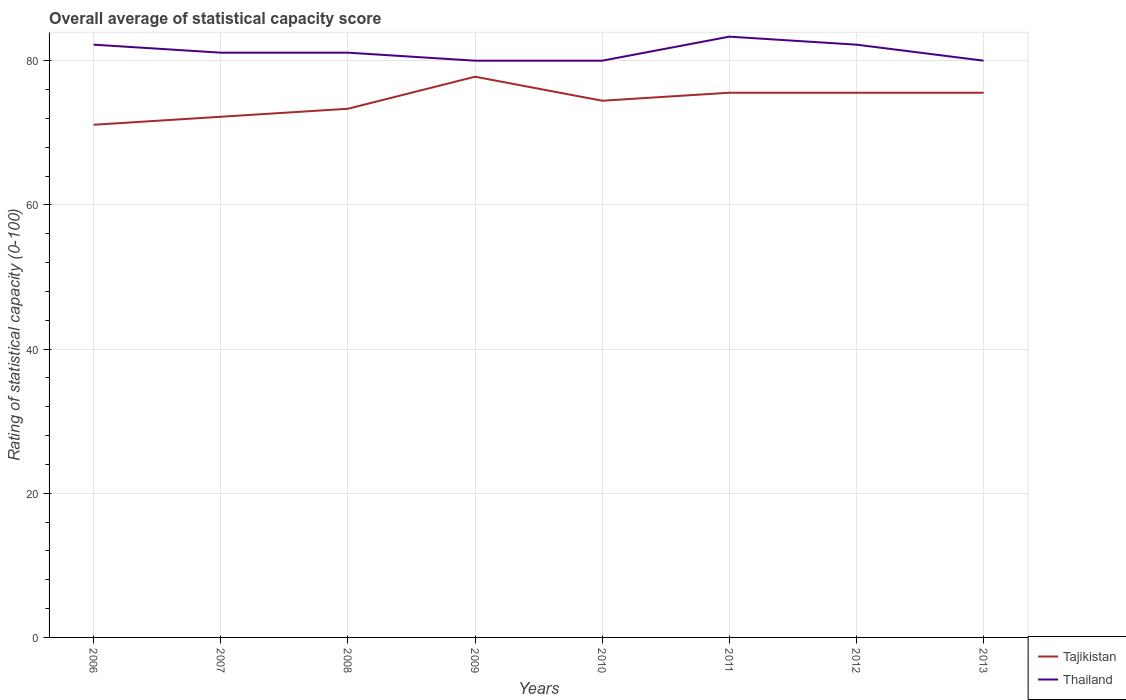Does the line corresponding to Thailand intersect with the line corresponding to Tajikistan?
Keep it short and to the point. No. Is the number of lines equal to the number of legend labels?
Make the answer very short. Yes. What is the total rating of statistical capacity in Tajikistan in the graph?
Offer a very short reply. -2.22. What is the difference between the highest and the second highest rating of statistical capacity in Thailand?
Keep it short and to the point. 3.33. How many lines are there?
Provide a succinct answer. 2. How many years are there in the graph?
Your answer should be compact. 8. Does the graph contain grids?
Keep it short and to the point. Yes. Where does the legend appear in the graph?
Keep it short and to the point. Bottom right. How are the legend labels stacked?
Your response must be concise. Vertical. What is the title of the graph?
Ensure brevity in your answer.  Overall average of statistical capacity score. Does "Liechtenstein" appear as one of the legend labels in the graph?
Keep it short and to the point. No. What is the label or title of the Y-axis?
Your answer should be very brief. Rating of statistical capacity (0-100). What is the Rating of statistical capacity (0-100) in Tajikistan in 2006?
Your answer should be compact. 71.11. What is the Rating of statistical capacity (0-100) in Thailand in 2006?
Keep it short and to the point. 82.22. What is the Rating of statistical capacity (0-100) of Tajikistan in 2007?
Offer a very short reply. 72.22. What is the Rating of statistical capacity (0-100) of Thailand in 2007?
Provide a succinct answer. 81.11. What is the Rating of statistical capacity (0-100) in Tajikistan in 2008?
Your answer should be compact. 73.33. What is the Rating of statistical capacity (0-100) in Thailand in 2008?
Your response must be concise. 81.11. What is the Rating of statistical capacity (0-100) of Tajikistan in 2009?
Offer a terse response. 77.78. What is the Rating of statistical capacity (0-100) of Tajikistan in 2010?
Provide a short and direct response. 74.44. What is the Rating of statistical capacity (0-100) of Tajikistan in 2011?
Provide a short and direct response. 75.56. What is the Rating of statistical capacity (0-100) in Thailand in 2011?
Give a very brief answer. 83.33. What is the Rating of statistical capacity (0-100) in Tajikistan in 2012?
Give a very brief answer. 75.56. What is the Rating of statistical capacity (0-100) of Thailand in 2012?
Ensure brevity in your answer.  82.22. What is the Rating of statistical capacity (0-100) in Tajikistan in 2013?
Your answer should be compact. 75.56. What is the Rating of statistical capacity (0-100) in Thailand in 2013?
Offer a terse response. 80. Across all years, what is the maximum Rating of statistical capacity (0-100) in Tajikistan?
Your answer should be compact. 77.78. Across all years, what is the maximum Rating of statistical capacity (0-100) in Thailand?
Give a very brief answer. 83.33. Across all years, what is the minimum Rating of statistical capacity (0-100) of Tajikistan?
Your response must be concise. 71.11. What is the total Rating of statistical capacity (0-100) in Tajikistan in the graph?
Provide a succinct answer. 595.56. What is the total Rating of statistical capacity (0-100) in Thailand in the graph?
Make the answer very short. 650. What is the difference between the Rating of statistical capacity (0-100) of Tajikistan in 2006 and that in 2007?
Your answer should be compact. -1.11. What is the difference between the Rating of statistical capacity (0-100) of Tajikistan in 2006 and that in 2008?
Give a very brief answer. -2.22. What is the difference between the Rating of statistical capacity (0-100) in Tajikistan in 2006 and that in 2009?
Your answer should be compact. -6.67. What is the difference between the Rating of statistical capacity (0-100) of Thailand in 2006 and that in 2009?
Ensure brevity in your answer.  2.22. What is the difference between the Rating of statistical capacity (0-100) in Thailand in 2006 and that in 2010?
Provide a succinct answer. 2.22. What is the difference between the Rating of statistical capacity (0-100) in Tajikistan in 2006 and that in 2011?
Your response must be concise. -4.44. What is the difference between the Rating of statistical capacity (0-100) in Thailand in 2006 and that in 2011?
Your response must be concise. -1.11. What is the difference between the Rating of statistical capacity (0-100) of Tajikistan in 2006 and that in 2012?
Offer a very short reply. -4.44. What is the difference between the Rating of statistical capacity (0-100) in Thailand in 2006 and that in 2012?
Provide a succinct answer. 0. What is the difference between the Rating of statistical capacity (0-100) of Tajikistan in 2006 and that in 2013?
Your answer should be very brief. -4.44. What is the difference between the Rating of statistical capacity (0-100) of Thailand in 2006 and that in 2013?
Your response must be concise. 2.22. What is the difference between the Rating of statistical capacity (0-100) of Tajikistan in 2007 and that in 2008?
Provide a short and direct response. -1.11. What is the difference between the Rating of statistical capacity (0-100) of Tajikistan in 2007 and that in 2009?
Keep it short and to the point. -5.56. What is the difference between the Rating of statistical capacity (0-100) of Tajikistan in 2007 and that in 2010?
Keep it short and to the point. -2.22. What is the difference between the Rating of statistical capacity (0-100) in Tajikistan in 2007 and that in 2011?
Give a very brief answer. -3.33. What is the difference between the Rating of statistical capacity (0-100) of Thailand in 2007 and that in 2011?
Your answer should be compact. -2.22. What is the difference between the Rating of statistical capacity (0-100) in Tajikistan in 2007 and that in 2012?
Your answer should be compact. -3.33. What is the difference between the Rating of statistical capacity (0-100) in Thailand in 2007 and that in 2012?
Your response must be concise. -1.11. What is the difference between the Rating of statistical capacity (0-100) of Tajikistan in 2008 and that in 2009?
Your response must be concise. -4.44. What is the difference between the Rating of statistical capacity (0-100) of Thailand in 2008 and that in 2009?
Provide a succinct answer. 1.11. What is the difference between the Rating of statistical capacity (0-100) in Tajikistan in 2008 and that in 2010?
Make the answer very short. -1.11. What is the difference between the Rating of statistical capacity (0-100) of Tajikistan in 2008 and that in 2011?
Ensure brevity in your answer.  -2.22. What is the difference between the Rating of statistical capacity (0-100) in Thailand in 2008 and that in 2011?
Provide a short and direct response. -2.22. What is the difference between the Rating of statistical capacity (0-100) in Tajikistan in 2008 and that in 2012?
Provide a short and direct response. -2.22. What is the difference between the Rating of statistical capacity (0-100) of Thailand in 2008 and that in 2012?
Provide a succinct answer. -1.11. What is the difference between the Rating of statistical capacity (0-100) in Tajikistan in 2008 and that in 2013?
Provide a short and direct response. -2.22. What is the difference between the Rating of statistical capacity (0-100) in Tajikistan in 2009 and that in 2010?
Offer a very short reply. 3.33. What is the difference between the Rating of statistical capacity (0-100) of Tajikistan in 2009 and that in 2011?
Offer a terse response. 2.22. What is the difference between the Rating of statistical capacity (0-100) of Thailand in 2009 and that in 2011?
Your response must be concise. -3.33. What is the difference between the Rating of statistical capacity (0-100) in Tajikistan in 2009 and that in 2012?
Ensure brevity in your answer.  2.22. What is the difference between the Rating of statistical capacity (0-100) in Thailand in 2009 and that in 2012?
Offer a terse response. -2.22. What is the difference between the Rating of statistical capacity (0-100) in Tajikistan in 2009 and that in 2013?
Ensure brevity in your answer.  2.22. What is the difference between the Rating of statistical capacity (0-100) of Thailand in 2009 and that in 2013?
Give a very brief answer. 0. What is the difference between the Rating of statistical capacity (0-100) in Tajikistan in 2010 and that in 2011?
Give a very brief answer. -1.11. What is the difference between the Rating of statistical capacity (0-100) in Thailand in 2010 and that in 2011?
Your response must be concise. -3.33. What is the difference between the Rating of statistical capacity (0-100) in Tajikistan in 2010 and that in 2012?
Your response must be concise. -1.11. What is the difference between the Rating of statistical capacity (0-100) of Thailand in 2010 and that in 2012?
Provide a short and direct response. -2.22. What is the difference between the Rating of statistical capacity (0-100) in Tajikistan in 2010 and that in 2013?
Ensure brevity in your answer.  -1.11. What is the difference between the Rating of statistical capacity (0-100) of Tajikistan in 2011 and that in 2012?
Offer a terse response. 0. What is the difference between the Rating of statistical capacity (0-100) in Tajikistan in 2011 and that in 2013?
Your answer should be compact. 0. What is the difference between the Rating of statistical capacity (0-100) in Thailand in 2011 and that in 2013?
Make the answer very short. 3.33. What is the difference between the Rating of statistical capacity (0-100) of Thailand in 2012 and that in 2013?
Ensure brevity in your answer.  2.22. What is the difference between the Rating of statistical capacity (0-100) of Tajikistan in 2006 and the Rating of statistical capacity (0-100) of Thailand in 2007?
Ensure brevity in your answer.  -10. What is the difference between the Rating of statistical capacity (0-100) in Tajikistan in 2006 and the Rating of statistical capacity (0-100) in Thailand in 2009?
Your response must be concise. -8.89. What is the difference between the Rating of statistical capacity (0-100) of Tajikistan in 2006 and the Rating of statistical capacity (0-100) of Thailand in 2010?
Make the answer very short. -8.89. What is the difference between the Rating of statistical capacity (0-100) in Tajikistan in 2006 and the Rating of statistical capacity (0-100) in Thailand in 2011?
Give a very brief answer. -12.22. What is the difference between the Rating of statistical capacity (0-100) in Tajikistan in 2006 and the Rating of statistical capacity (0-100) in Thailand in 2012?
Offer a very short reply. -11.11. What is the difference between the Rating of statistical capacity (0-100) in Tajikistan in 2006 and the Rating of statistical capacity (0-100) in Thailand in 2013?
Keep it short and to the point. -8.89. What is the difference between the Rating of statistical capacity (0-100) in Tajikistan in 2007 and the Rating of statistical capacity (0-100) in Thailand in 2008?
Offer a terse response. -8.89. What is the difference between the Rating of statistical capacity (0-100) in Tajikistan in 2007 and the Rating of statistical capacity (0-100) in Thailand in 2009?
Your answer should be compact. -7.78. What is the difference between the Rating of statistical capacity (0-100) of Tajikistan in 2007 and the Rating of statistical capacity (0-100) of Thailand in 2010?
Ensure brevity in your answer.  -7.78. What is the difference between the Rating of statistical capacity (0-100) of Tajikistan in 2007 and the Rating of statistical capacity (0-100) of Thailand in 2011?
Provide a succinct answer. -11.11. What is the difference between the Rating of statistical capacity (0-100) of Tajikistan in 2007 and the Rating of statistical capacity (0-100) of Thailand in 2013?
Your answer should be compact. -7.78. What is the difference between the Rating of statistical capacity (0-100) of Tajikistan in 2008 and the Rating of statistical capacity (0-100) of Thailand in 2009?
Ensure brevity in your answer.  -6.67. What is the difference between the Rating of statistical capacity (0-100) in Tajikistan in 2008 and the Rating of statistical capacity (0-100) in Thailand in 2010?
Provide a succinct answer. -6.67. What is the difference between the Rating of statistical capacity (0-100) of Tajikistan in 2008 and the Rating of statistical capacity (0-100) of Thailand in 2011?
Your answer should be compact. -10. What is the difference between the Rating of statistical capacity (0-100) in Tajikistan in 2008 and the Rating of statistical capacity (0-100) in Thailand in 2012?
Your answer should be compact. -8.89. What is the difference between the Rating of statistical capacity (0-100) in Tajikistan in 2008 and the Rating of statistical capacity (0-100) in Thailand in 2013?
Your answer should be very brief. -6.67. What is the difference between the Rating of statistical capacity (0-100) of Tajikistan in 2009 and the Rating of statistical capacity (0-100) of Thailand in 2010?
Provide a short and direct response. -2.22. What is the difference between the Rating of statistical capacity (0-100) in Tajikistan in 2009 and the Rating of statistical capacity (0-100) in Thailand in 2011?
Make the answer very short. -5.56. What is the difference between the Rating of statistical capacity (0-100) in Tajikistan in 2009 and the Rating of statistical capacity (0-100) in Thailand in 2012?
Give a very brief answer. -4.44. What is the difference between the Rating of statistical capacity (0-100) of Tajikistan in 2009 and the Rating of statistical capacity (0-100) of Thailand in 2013?
Keep it short and to the point. -2.22. What is the difference between the Rating of statistical capacity (0-100) in Tajikistan in 2010 and the Rating of statistical capacity (0-100) in Thailand in 2011?
Offer a terse response. -8.89. What is the difference between the Rating of statistical capacity (0-100) of Tajikistan in 2010 and the Rating of statistical capacity (0-100) of Thailand in 2012?
Make the answer very short. -7.78. What is the difference between the Rating of statistical capacity (0-100) of Tajikistan in 2010 and the Rating of statistical capacity (0-100) of Thailand in 2013?
Keep it short and to the point. -5.56. What is the difference between the Rating of statistical capacity (0-100) of Tajikistan in 2011 and the Rating of statistical capacity (0-100) of Thailand in 2012?
Give a very brief answer. -6.67. What is the difference between the Rating of statistical capacity (0-100) in Tajikistan in 2011 and the Rating of statistical capacity (0-100) in Thailand in 2013?
Provide a short and direct response. -4.44. What is the difference between the Rating of statistical capacity (0-100) of Tajikistan in 2012 and the Rating of statistical capacity (0-100) of Thailand in 2013?
Ensure brevity in your answer.  -4.44. What is the average Rating of statistical capacity (0-100) of Tajikistan per year?
Keep it short and to the point. 74.44. What is the average Rating of statistical capacity (0-100) in Thailand per year?
Offer a terse response. 81.25. In the year 2006, what is the difference between the Rating of statistical capacity (0-100) of Tajikistan and Rating of statistical capacity (0-100) of Thailand?
Offer a terse response. -11.11. In the year 2007, what is the difference between the Rating of statistical capacity (0-100) in Tajikistan and Rating of statistical capacity (0-100) in Thailand?
Give a very brief answer. -8.89. In the year 2008, what is the difference between the Rating of statistical capacity (0-100) in Tajikistan and Rating of statistical capacity (0-100) in Thailand?
Keep it short and to the point. -7.78. In the year 2009, what is the difference between the Rating of statistical capacity (0-100) of Tajikistan and Rating of statistical capacity (0-100) of Thailand?
Provide a short and direct response. -2.22. In the year 2010, what is the difference between the Rating of statistical capacity (0-100) of Tajikistan and Rating of statistical capacity (0-100) of Thailand?
Offer a terse response. -5.56. In the year 2011, what is the difference between the Rating of statistical capacity (0-100) of Tajikistan and Rating of statistical capacity (0-100) of Thailand?
Offer a very short reply. -7.78. In the year 2012, what is the difference between the Rating of statistical capacity (0-100) of Tajikistan and Rating of statistical capacity (0-100) of Thailand?
Keep it short and to the point. -6.67. In the year 2013, what is the difference between the Rating of statistical capacity (0-100) in Tajikistan and Rating of statistical capacity (0-100) in Thailand?
Your response must be concise. -4.44. What is the ratio of the Rating of statistical capacity (0-100) in Tajikistan in 2006 to that in 2007?
Your response must be concise. 0.98. What is the ratio of the Rating of statistical capacity (0-100) in Thailand in 2006 to that in 2007?
Your response must be concise. 1.01. What is the ratio of the Rating of statistical capacity (0-100) in Tajikistan in 2006 to that in 2008?
Your answer should be very brief. 0.97. What is the ratio of the Rating of statistical capacity (0-100) in Thailand in 2006 to that in 2008?
Your answer should be very brief. 1.01. What is the ratio of the Rating of statistical capacity (0-100) in Tajikistan in 2006 to that in 2009?
Provide a succinct answer. 0.91. What is the ratio of the Rating of statistical capacity (0-100) of Thailand in 2006 to that in 2009?
Your answer should be very brief. 1.03. What is the ratio of the Rating of statistical capacity (0-100) in Tajikistan in 2006 to that in 2010?
Provide a short and direct response. 0.96. What is the ratio of the Rating of statistical capacity (0-100) in Thailand in 2006 to that in 2010?
Your answer should be very brief. 1.03. What is the ratio of the Rating of statistical capacity (0-100) in Tajikistan in 2006 to that in 2011?
Offer a very short reply. 0.94. What is the ratio of the Rating of statistical capacity (0-100) in Thailand in 2006 to that in 2011?
Your answer should be very brief. 0.99. What is the ratio of the Rating of statistical capacity (0-100) in Thailand in 2006 to that in 2013?
Your response must be concise. 1.03. What is the ratio of the Rating of statistical capacity (0-100) in Tajikistan in 2007 to that in 2008?
Provide a succinct answer. 0.98. What is the ratio of the Rating of statistical capacity (0-100) in Tajikistan in 2007 to that in 2009?
Keep it short and to the point. 0.93. What is the ratio of the Rating of statistical capacity (0-100) of Thailand in 2007 to that in 2009?
Ensure brevity in your answer.  1.01. What is the ratio of the Rating of statistical capacity (0-100) in Tajikistan in 2007 to that in 2010?
Offer a terse response. 0.97. What is the ratio of the Rating of statistical capacity (0-100) in Thailand in 2007 to that in 2010?
Ensure brevity in your answer.  1.01. What is the ratio of the Rating of statistical capacity (0-100) of Tajikistan in 2007 to that in 2011?
Your response must be concise. 0.96. What is the ratio of the Rating of statistical capacity (0-100) in Thailand in 2007 to that in 2011?
Keep it short and to the point. 0.97. What is the ratio of the Rating of statistical capacity (0-100) in Tajikistan in 2007 to that in 2012?
Ensure brevity in your answer.  0.96. What is the ratio of the Rating of statistical capacity (0-100) of Thailand in 2007 to that in 2012?
Ensure brevity in your answer.  0.99. What is the ratio of the Rating of statistical capacity (0-100) of Tajikistan in 2007 to that in 2013?
Ensure brevity in your answer.  0.96. What is the ratio of the Rating of statistical capacity (0-100) in Thailand in 2007 to that in 2013?
Offer a very short reply. 1.01. What is the ratio of the Rating of statistical capacity (0-100) of Tajikistan in 2008 to that in 2009?
Your answer should be very brief. 0.94. What is the ratio of the Rating of statistical capacity (0-100) in Thailand in 2008 to that in 2009?
Give a very brief answer. 1.01. What is the ratio of the Rating of statistical capacity (0-100) of Tajikistan in 2008 to that in 2010?
Your answer should be very brief. 0.99. What is the ratio of the Rating of statistical capacity (0-100) in Thailand in 2008 to that in 2010?
Offer a terse response. 1.01. What is the ratio of the Rating of statistical capacity (0-100) of Tajikistan in 2008 to that in 2011?
Your response must be concise. 0.97. What is the ratio of the Rating of statistical capacity (0-100) in Thailand in 2008 to that in 2011?
Your answer should be compact. 0.97. What is the ratio of the Rating of statistical capacity (0-100) of Tajikistan in 2008 to that in 2012?
Offer a very short reply. 0.97. What is the ratio of the Rating of statistical capacity (0-100) in Thailand in 2008 to that in 2012?
Your answer should be compact. 0.99. What is the ratio of the Rating of statistical capacity (0-100) in Tajikistan in 2008 to that in 2013?
Your response must be concise. 0.97. What is the ratio of the Rating of statistical capacity (0-100) in Thailand in 2008 to that in 2013?
Your response must be concise. 1.01. What is the ratio of the Rating of statistical capacity (0-100) in Tajikistan in 2009 to that in 2010?
Your response must be concise. 1.04. What is the ratio of the Rating of statistical capacity (0-100) in Thailand in 2009 to that in 2010?
Your answer should be compact. 1. What is the ratio of the Rating of statistical capacity (0-100) in Tajikistan in 2009 to that in 2011?
Offer a terse response. 1.03. What is the ratio of the Rating of statistical capacity (0-100) in Thailand in 2009 to that in 2011?
Offer a very short reply. 0.96. What is the ratio of the Rating of statistical capacity (0-100) in Tajikistan in 2009 to that in 2012?
Ensure brevity in your answer.  1.03. What is the ratio of the Rating of statistical capacity (0-100) of Tajikistan in 2009 to that in 2013?
Make the answer very short. 1.03. What is the ratio of the Rating of statistical capacity (0-100) in Thailand in 2009 to that in 2013?
Offer a very short reply. 1. What is the ratio of the Rating of statistical capacity (0-100) in Tajikistan in 2010 to that in 2011?
Offer a very short reply. 0.99. What is the ratio of the Rating of statistical capacity (0-100) in Tajikistan in 2010 to that in 2012?
Provide a short and direct response. 0.99. What is the ratio of the Rating of statistical capacity (0-100) in Thailand in 2010 to that in 2012?
Offer a very short reply. 0.97. What is the ratio of the Rating of statistical capacity (0-100) in Thailand in 2011 to that in 2012?
Provide a short and direct response. 1.01. What is the ratio of the Rating of statistical capacity (0-100) of Thailand in 2011 to that in 2013?
Give a very brief answer. 1.04. What is the ratio of the Rating of statistical capacity (0-100) of Thailand in 2012 to that in 2013?
Ensure brevity in your answer.  1.03. What is the difference between the highest and the second highest Rating of statistical capacity (0-100) of Tajikistan?
Provide a short and direct response. 2.22. What is the difference between the highest and the second highest Rating of statistical capacity (0-100) of Thailand?
Your answer should be very brief. 1.11. What is the difference between the highest and the lowest Rating of statistical capacity (0-100) of Thailand?
Offer a terse response. 3.33. 